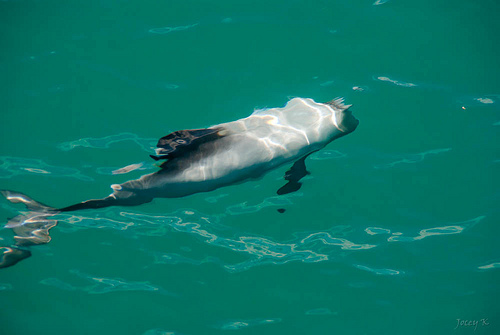<image>
Can you confirm if the fish is to the left of the water? No. The fish is not to the left of the water. From this viewpoint, they have a different horizontal relationship. Is the fish under the water? Yes. The fish is positioned underneath the water, with the water above it in the vertical space. 